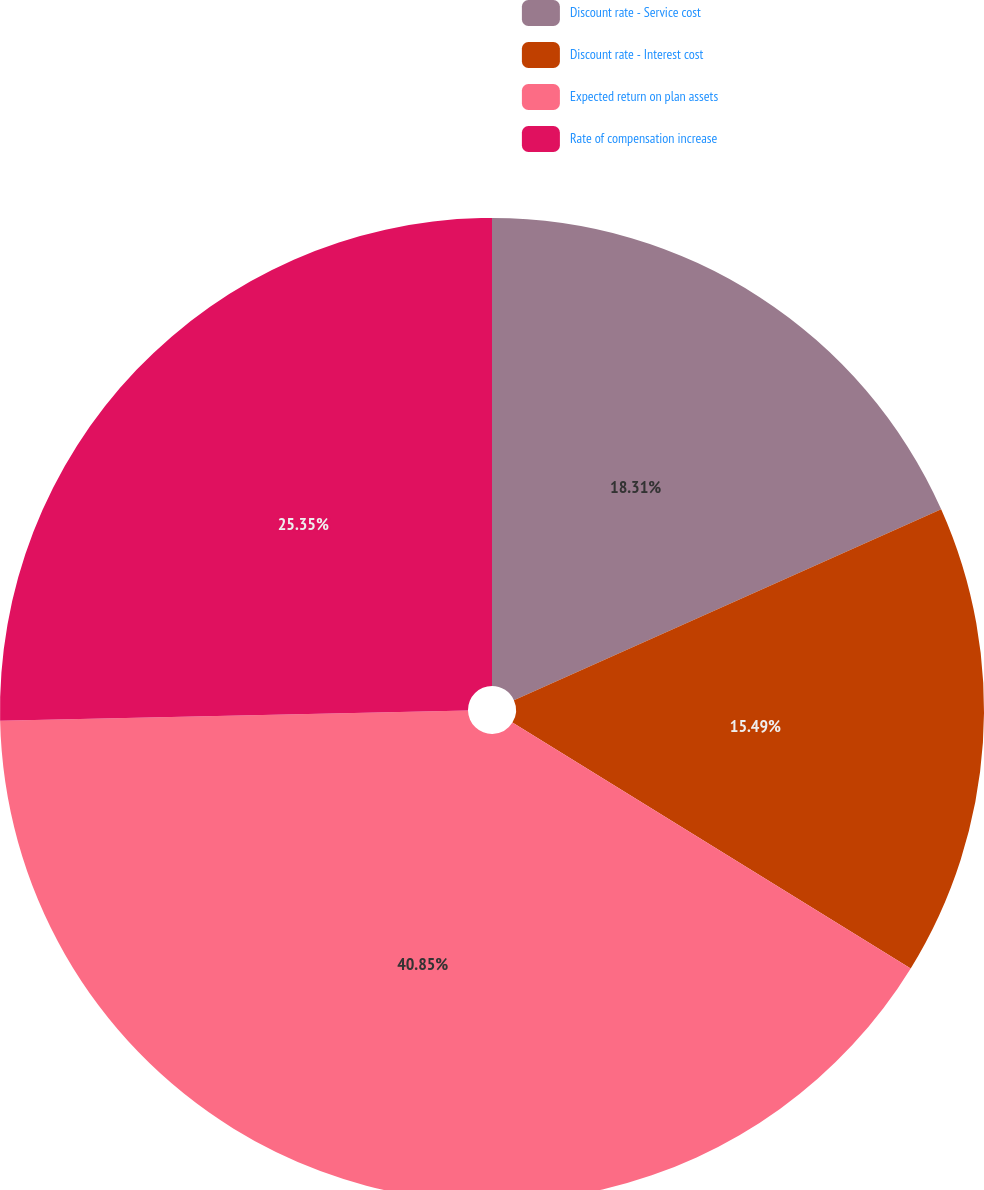Convert chart to OTSL. <chart><loc_0><loc_0><loc_500><loc_500><pie_chart><fcel>Discount rate - Service cost<fcel>Discount rate - Interest cost<fcel>Expected return on plan assets<fcel>Rate of compensation increase<nl><fcel>18.31%<fcel>15.49%<fcel>40.85%<fcel>25.35%<nl></chart> 